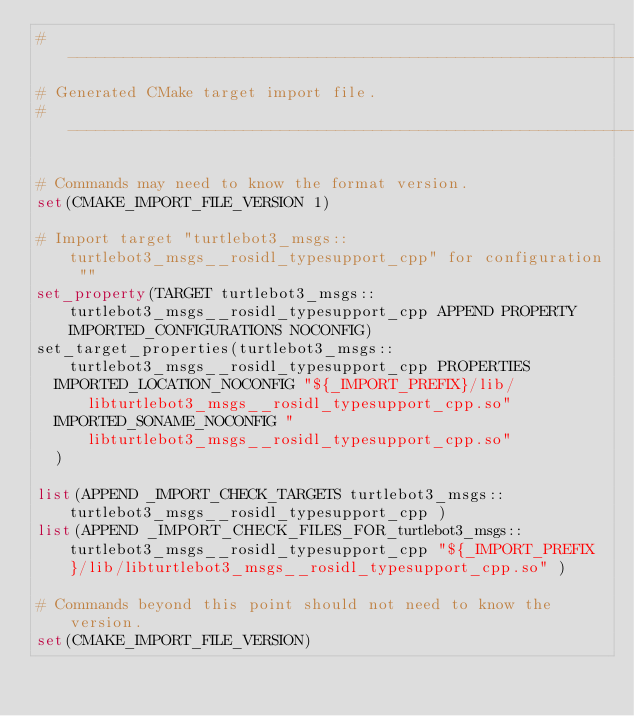<code> <loc_0><loc_0><loc_500><loc_500><_CMake_>#----------------------------------------------------------------
# Generated CMake target import file.
#----------------------------------------------------------------

# Commands may need to know the format version.
set(CMAKE_IMPORT_FILE_VERSION 1)

# Import target "turtlebot3_msgs::turtlebot3_msgs__rosidl_typesupport_cpp" for configuration ""
set_property(TARGET turtlebot3_msgs::turtlebot3_msgs__rosidl_typesupport_cpp APPEND PROPERTY IMPORTED_CONFIGURATIONS NOCONFIG)
set_target_properties(turtlebot3_msgs::turtlebot3_msgs__rosidl_typesupport_cpp PROPERTIES
  IMPORTED_LOCATION_NOCONFIG "${_IMPORT_PREFIX}/lib/libturtlebot3_msgs__rosidl_typesupport_cpp.so"
  IMPORTED_SONAME_NOCONFIG "libturtlebot3_msgs__rosidl_typesupport_cpp.so"
  )

list(APPEND _IMPORT_CHECK_TARGETS turtlebot3_msgs::turtlebot3_msgs__rosidl_typesupport_cpp )
list(APPEND _IMPORT_CHECK_FILES_FOR_turtlebot3_msgs::turtlebot3_msgs__rosidl_typesupport_cpp "${_IMPORT_PREFIX}/lib/libturtlebot3_msgs__rosidl_typesupport_cpp.so" )

# Commands beyond this point should not need to know the version.
set(CMAKE_IMPORT_FILE_VERSION)
</code> 